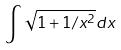Convert formula to latex. <formula><loc_0><loc_0><loc_500><loc_500>\int \sqrt { 1 + 1 / x ^ { 2 } } d x</formula> 